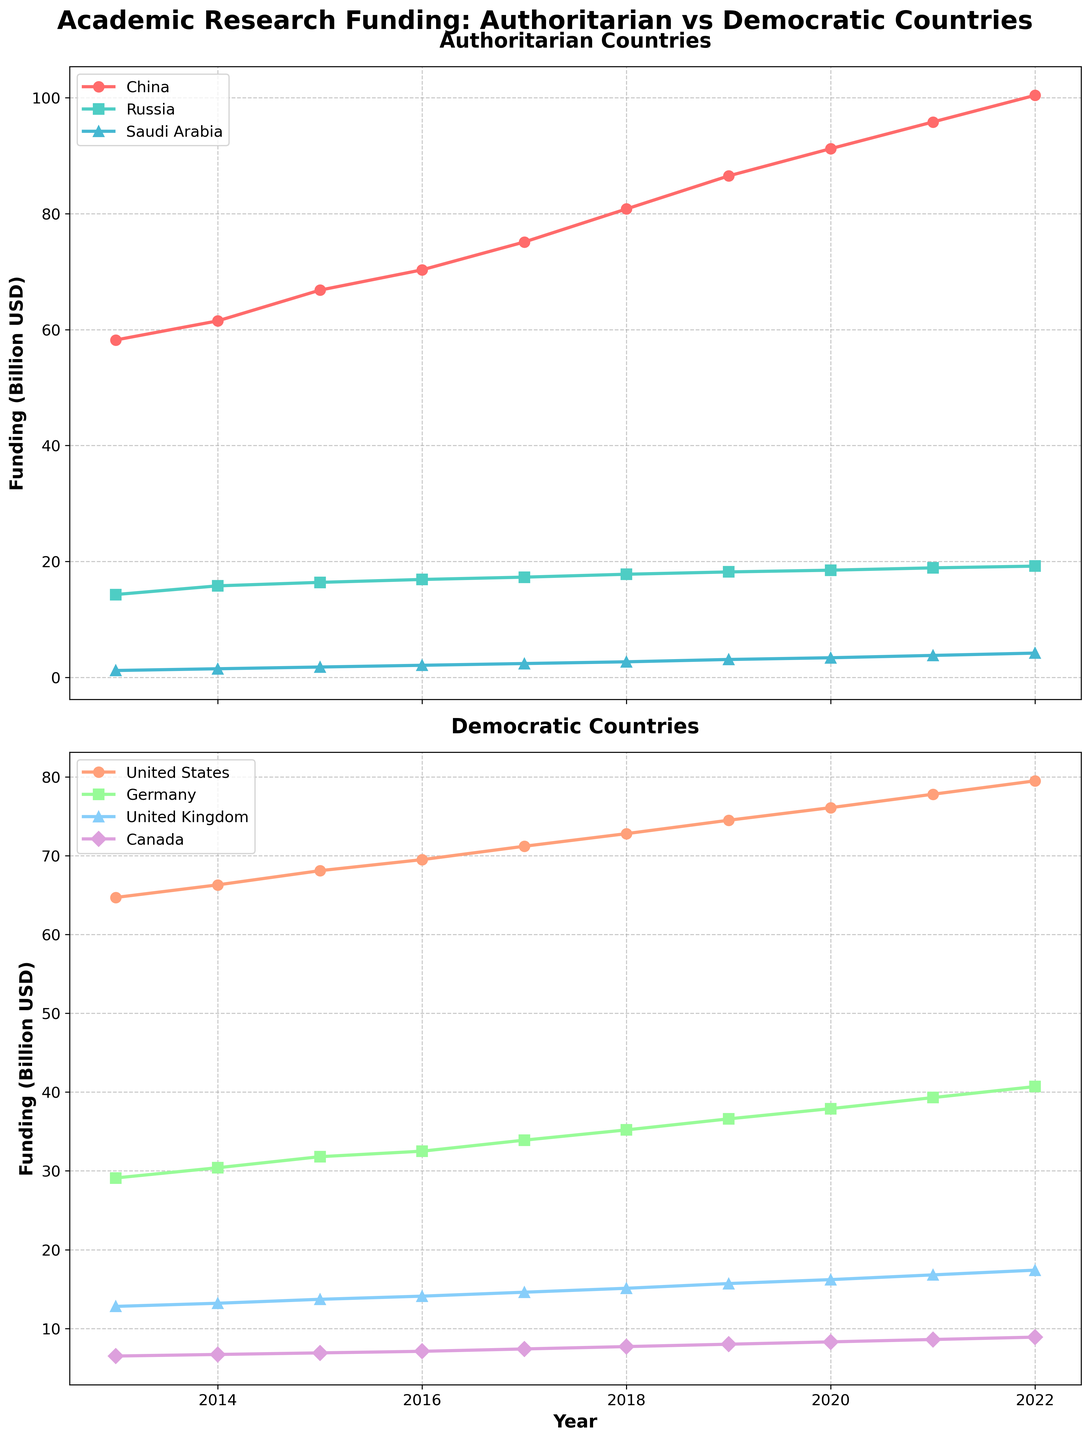what are the titles of the two subplots? The titles of the two subplots are written at the top of each subplot. The first subplot's title is "Authoritarian Countries," and the second subplot's title is "Democratic Countries."
Answer: "Authoritarian Countries" (top) and "Democratic Countries" (bottom) what is the general trend of research funding in China over the last decade? By looking at the line corresponding to China in the top subplot, it is evident that the research funding has been increasing continuously from 2013 to 2022.
Answer: Increasing which country among authoritarian nations had the lowest funding in 2022? Look at the endpoints of the lines in the top subplot for 2022. The line representing Saudi Arabia ends at the lowest value compared to China and Russia.
Answer: Saudi Arabia what was the funding difference between the United States and Canada in 2020? Locate the points for 2020 on the lines representing the United States and Canada in the bottom subplot. The funding for the United States in 2020 was 76.1 billion USD and for Canada was 8.3 billion USD. Calculate the difference: 76.1 - 8.3 = 67.8 billion USD.
Answer: 67.8 billion USD how did Germany's funding change from 2013 to 2022? Track the line for Germany from its start in 2013 to its end in 2022 in the bottom subplot. The funding increased from 29.1 billion USD in 2013 to 40.7 billion USD in 2022.
Answer: Increased which country had the most significant funding increase among democratic countries between 2013 and 2022? Compare the differences in funding from 2013 to 2022 for all democratic countries in the bottom subplot: United States, Germany, United Kingdom, and Canada. Calculate the increases for each: United States (14.8 billion USD), Germany (11.6 billion USD), United Kingdom (4.6 billion USD), and Canada (2.4 billion USD). The United States had the most significant increase.
Answer: United States how does research funding in Russia compare to that in the United Kingdom in 2016? Find the data points for both Russia and the United Kingdom in 2016 in their respective subplots. Russia's funding was 16.9 billion USD, and the United Kingdom's funding was 14.1 billion USD. Russia's funding was higher.
Answer: Russia's funding was higher what is the average funding level of Saudi Arabia over the decade? Record the funding values for Saudi Arabia from 2013 to 2022 in the top subplot: 1.2, 1.5, 1.8, 2.1, 2.4, 2.7, 3.1, 3.4, 3.8, 4.2 billion USD. Sum these values and then divide by 10 (total years): (1.2 + 1.5 + 1.8 + 2.1 + 2.4 + 2.7 + 3.1 + 3.4 + 3.8 + 4.2) / 10 = 2.72 billion USD.
Answer: 2.72 billion USD 